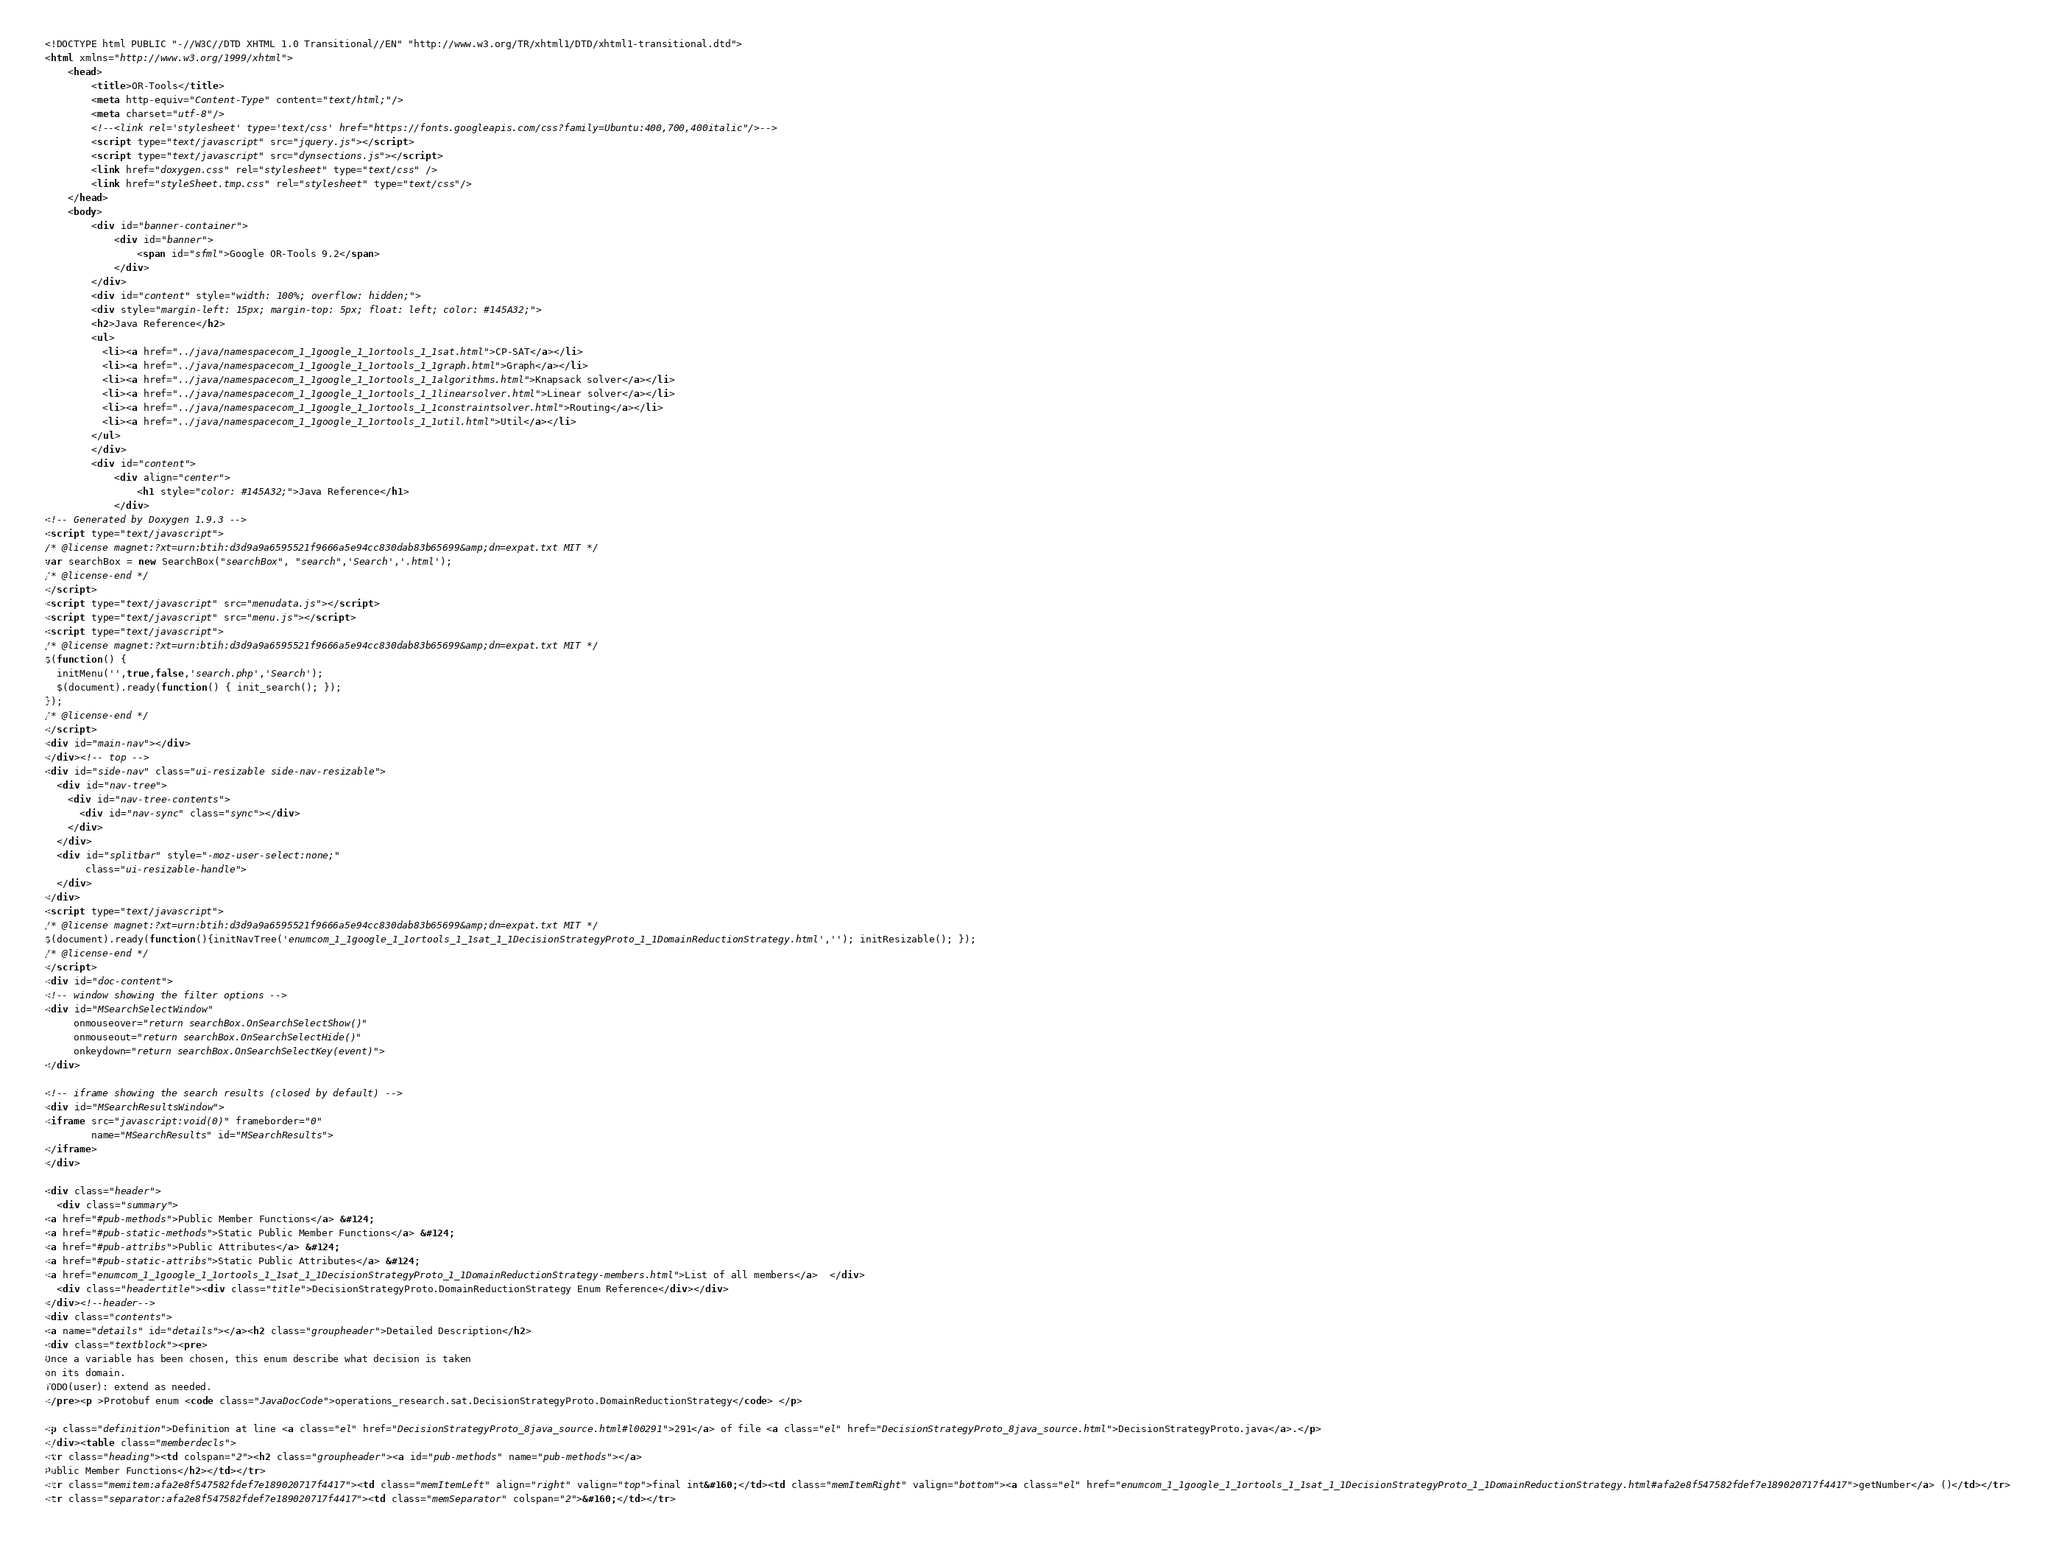<code> <loc_0><loc_0><loc_500><loc_500><_HTML_><!DOCTYPE html PUBLIC "-//W3C//DTD XHTML 1.0 Transitional//EN" "http://www.w3.org/TR/xhtml1/DTD/xhtml1-transitional.dtd">
<html xmlns="http://www.w3.org/1999/xhtml">
    <head>
        <title>OR-Tools</title>
        <meta http-equiv="Content-Type" content="text/html;"/>
        <meta charset="utf-8"/>
        <!--<link rel='stylesheet' type='text/css' href="https://fonts.googleapis.com/css?family=Ubuntu:400,700,400italic"/>-->
        <script type="text/javascript" src="jquery.js"></script>
        <script type="text/javascript" src="dynsections.js"></script>
        <link href="doxygen.css" rel="stylesheet" type="text/css" />
        <link href="styleSheet.tmp.css" rel="stylesheet" type="text/css"/>
    </head>
    <body>
        <div id="banner-container">
            <div id="banner">
                <span id="sfml">Google OR-Tools 9.2</span>
            </div>
        </div>
        <div id="content" style="width: 100%; overflow: hidden;">
        <div style="margin-left: 15px; margin-top: 5px; float: left; color: #145A32;">
        <h2>Java Reference</h2>
        <ul>
          <li><a href="../java/namespacecom_1_1google_1_1ortools_1_1sat.html">CP-SAT</a></li>
          <li><a href="../java/namespacecom_1_1google_1_1ortools_1_1graph.html">Graph</a></li>
          <li><a href="../java/namespacecom_1_1google_1_1ortools_1_1algorithms.html">Knapsack solver</a></li>
          <li><a href="../java/namespacecom_1_1google_1_1ortools_1_1linearsolver.html">Linear solver</a></li>
          <li><a href="../java/namespacecom_1_1google_1_1ortools_1_1constraintsolver.html">Routing</a></li>
          <li><a href="../java/namespacecom_1_1google_1_1ortools_1_1util.html">Util</a></li>
        </ul>
        </div>
        <div id="content">
            <div align="center">
                <h1 style="color: #145A32;">Java Reference</h1>
            </div>
<!-- Generated by Doxygen 1.9.3 -->
<script type="text/javascript">
/* @license magnet:?xt=urn:btih:d3d9a9a6595521f9666a5e94cc830dab83b65699&amp;dn=expat.txt MIT */
var searchBox = new SearchBox("searchBox", "search",'Search','.html');
/* @license-end */
</script>
<script type="text/javascript" src="menudata.js"></script>
<script type="text/javascript" src="menu.js"></script>
<script type="text/javascript">
/* @license magnet:?xt=urn:btih:d3d9a9a6595521f9666a5e94cc830dab83b65699&amp;dn=expat.txt MIT */
$(function() {
  initMenu('',true,false,'search.php','Search');
  $(document).ready(function() { init_search(); });
});
/* @license-end */
</script>
<div id="main-nav"></div>
</div><!-- top -->
<div id="side-nav" class="ui-resizable side-nav-resizable">
  <div id="nav-tree">
    <div id="nav-tree-contents">
      <div id="nav-sync" class="sync"></div>
    </div>
  </div>
  <div id="splitbar" style="-moz-user-select:none;" 
       class="ui-resizable-handle">
  </div>
</div>
<script type="text/javascript">
/* @license magnet:?xt=urn:btih:d3d9a9a6595521f9666a5e94cc830dab83b65699&amp;dn=expat.txt MIT */
$(document).ready(function(){initNavTree('enumcom_1_1google_1_1ortools_1_1sat_1_1DecisionStrategyProto_1_1DomainReductionStrategy.html',''); initResizable(); });
/* @license-end */
</script>
<div id="doc-content">
<!-- window showing the filter options -->
<div id="MSearchSelectWindow"
     onmouseover="return searchBox.OnSearchSelectShow()"
     onmouseout="return searchBox.OnSearchSelectHide()"
     onkeydown="return searchBox.OnSearchSelectKey(event)">
</div>

<!-- iframe showing the search results (closed by default) -->
<div id="MSearchResultsWindow">
<iframe src="javascript:void(0)" frameborder="0" 
        name="MSearchResults" id="MSearchResults">
</iframe>
</div>

<div class="header">
  <div class="summary">
<a href="#pub-methods">Public Member Functions</a> &#124;
<a href="#pub-static-methods">Static Public Member Functions</a> &#124;
<a href="#pub-attribs">Public Attributes</a> &#124;
<a href="#pub-static-attribs">Static Public Attributes</a> &#124;
<a href="enumcom_1_1google_1_1ortools_1_1sat_1_1DecisionStrategyProto_1_1DomainReductionStrategy-members.html">List of all members</a>  </div>
  <div class="headertitle"><div class="title">DecisionStrategyProto.DomainReductionStrategy Enum Reference</div></div>
</div><!--header-->
<div class="contents">
<a name="details" id="details"></a><h2 class="groupheader">Detailed Description</h2>
<div class="textblock"><pre>
Once a variable has been chosen, this enum describe what decision is taken
on its domain.
TODO(user): extend as needed.
</pre><p >Protobuf enum <code class="JavaDocCode">operations_research.sat.DecisionStrategyProto.DomainReductionStrategy</code> </p>

<p class="definition">Definition at line <a class="el" href="DecisionStrategyProto_8java_source.html#l00291">291</a> of file <a class="el" href="DecisionStrategyProto_8java_source.html">DecisionStrategyProto.java</a>.</p>
</div><table class="memberdecls">
<tr class="heading"><td colspan="2"><h2 class="groupheader"><a id="pub-methods" name="pub-methods"></a>
Public Member Functions</h2></td></tr>
<tr class="memitem:afa2e8f547582fdef7e189020717f4417"><td class="memItemLeft" align="right" valign="top">final int&#160;</td><td class="memItemRight" valign="bottom"><a class="el" href="enumcom_1_1google_1_1ortools_1_1sat_1_1DecisionStrategyProto_1_1DomainReductionStrategy.html#afa2e8f547582fdef7e189020717f4417">getNumber</a> ()</td></tr>
<tr class="separator:afa2e8f547582fdef7e189020717f4417"><td class="memSeparator" colspan="2">&#160;</td></tr></code> 